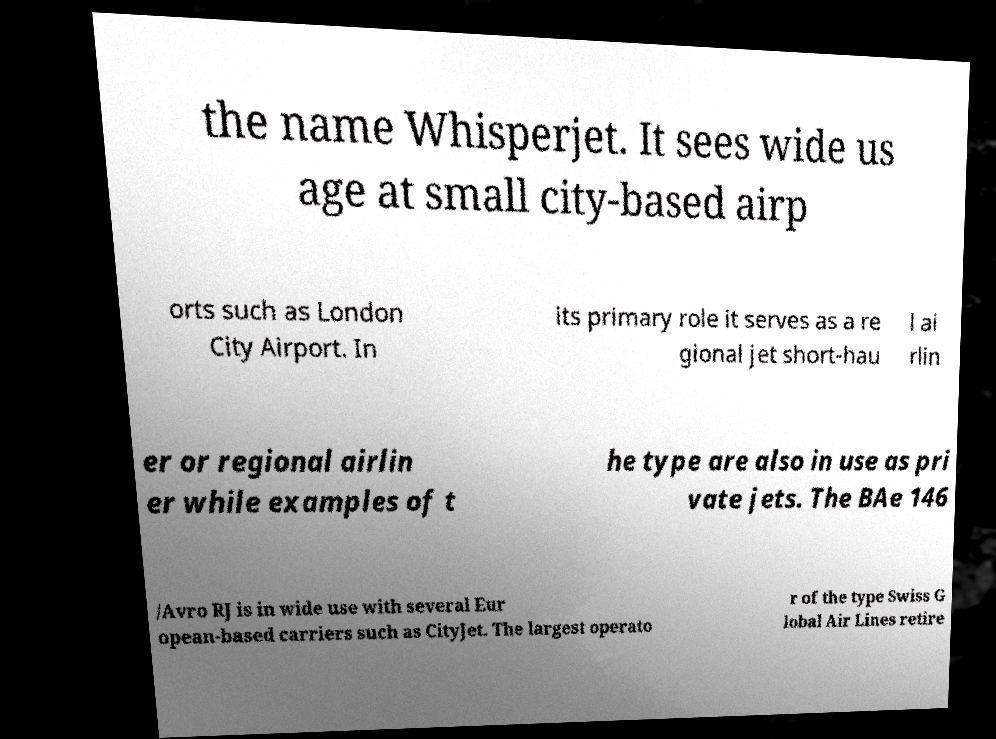What messages or text are displayed in this image? I need them in a readable, typed format. the name Whisperjet. It sees wide us age at small city-based airp orts such as London City Airport. In its primary role it serves as a re gional jet short-hau l ai rlin er or regional airlin er while examples of t he type are also in use as pri vate jets. The BAe 146 /Avro RJ is in wide use with several Eur opean-based carriers such as CityJet. The largest operato r of the type Swiss G lobal Air Lines retire 